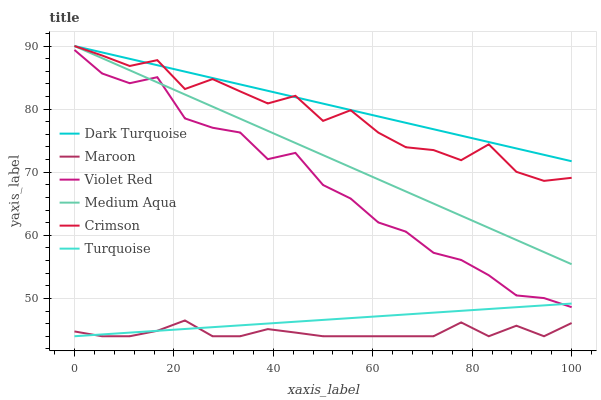Does Maroon have the minimum area under the curve?
Answer yes or no. Yes. Does Dark Turquoise have the maximum area under the curve?
Answer yes or no. Yes. Does Turquoise have the minimum area under the curve?
Answer yes or no. No. Does Turquoise have the maximum area under the curve?
Answer yes or no. No. Is Turquoise the smoothest?
Answer yes or no. Yes. Is Crimson the roughest?
Answer yes or no. Yes. Is Dark Turquoise the smoothest?
Answer yes or no. No. Is Dark Turquoise the roughest?
Answer yes or no. No. Does Dark Turquoise have the lowest value?
Answer yes or no. No. Does Crimson have the highest value?
Answer yes or no. Yes. Does Turquoise have the highest value?
Answer yes or no. No. Is Maroon less than Violet Red?
Answer yes or no. Yes. Is Crimson greater than Violet Red?
Answer yes or no. Yes. Does Maroon intersect Turquoise?
Answer yes or no. Yes. Is Maroon less than Turquoise?
Answer yes or no. No. Is Maroon greater than Turquoise?
Answer yes or no. No. Does Maroon intersect Violet Red?
Answer yes or no. No. 